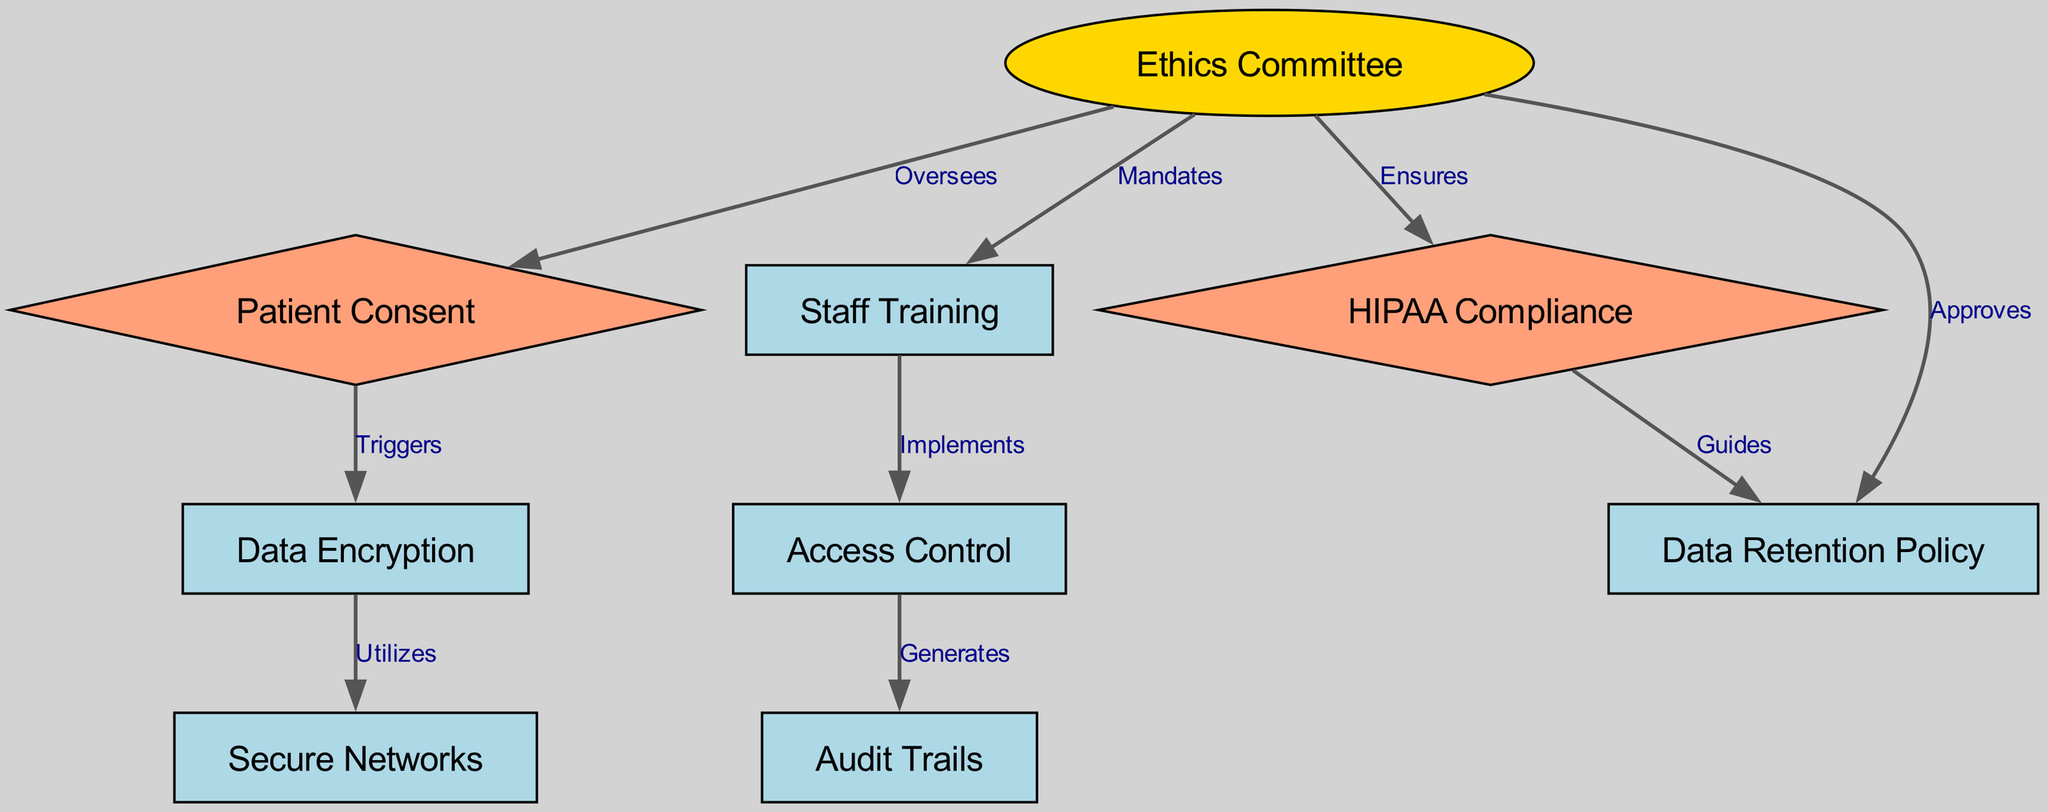What is the total number of nodes in the diagram? The diagram consists of a defined list of nodes which includes: Ethics Committee, Patient Consent, Data Encryption, Access Control, Audit Trails, Staff Training, HIPAA Compliance, Secure Networks, and Data Retention Policy. Counting these gives a total of 9 nodes.
Answer: 9 Which node is mandated by the Ethics Committee? The Ethics Committee mandates Staff Training, as indicated by the directed edge from the Ethics Committee to Staff Training labeled "Mandates".
Answer: Staff Training What relationship exists between Data Encryption and Secure Networks? The relationship is that Data Encryption utilizes Secure Networks. This is shown in the directed edge connecting Data Encryption to Secure Networks with the label "Utilizes".
Answer: Utilizes How many edges are there in total? The diagram lists relationships or connections between various nodes, where each connection is represented as an edge. Counting these connections gives a total of 8 edges.
Answer: 8 Which node is triggered by Patient Consent? The node that is triggered by Patient Consent is Data Encryption. This relationship is represented by a directed edge from Patient Consent to Data Encryption, labeled "Triggers".
Answer: Data Encryption What role does the Ethics Committee play in HIPAA Compliance? The Ethics Committee ensures HIPAA Compliance, as indicated by the directed edge from the Ethics Committee to HIPAA Compliance labeled "Ensures".
Answer: Ensures Which node guides the Data Retention Policy? The node that guides the Data Retention Policy is HIPAA Compliance. This is reflected in the directed edge from HIPAA Compliance to Data Retention Policy with the label "Guides".
Answer: HIPAA Compliance Which two nodes are connected by the label "Generates"? The two nodes connected by the label "Generates" are Access Control and Audit Trails. This relationship is depicted by the directed edge going from Access Control to Audit Trails.
Answer: Access Control and Audit Trails What is the decision-making process regarding Data Retention Policy as per the Ethics Committee? The Ethics Committee approves the Data Retention Policy, which is represented by the directed edge from the Ethics Committee to Data Retention Policy with the label "Approves".
Answer: Approves 